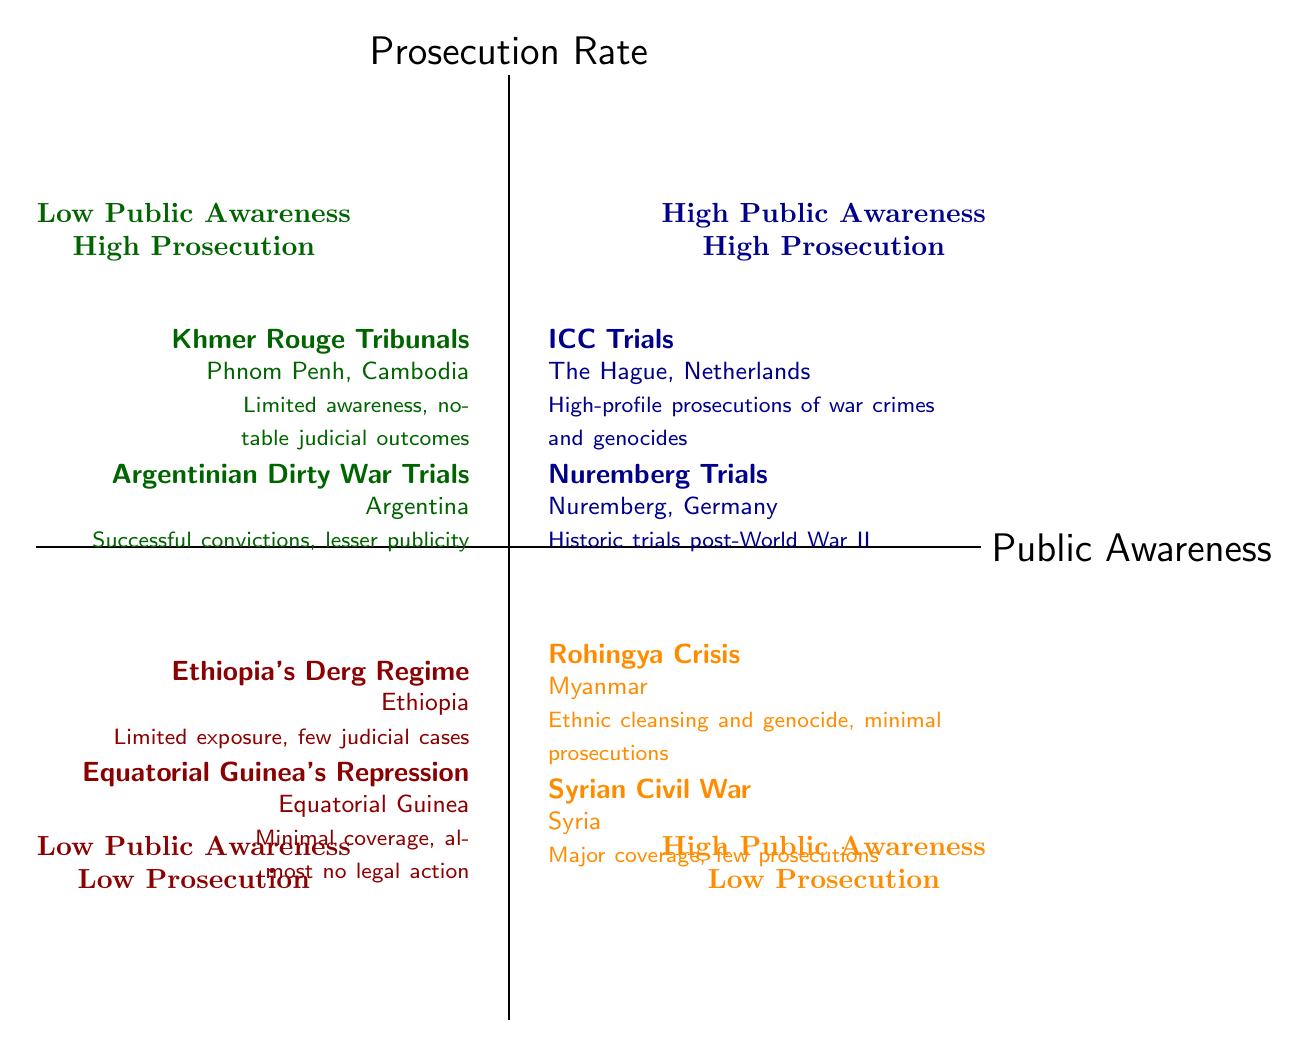What cases are located in the High Public Awareness and Low Prosecution quadrant? In the diagram, the quadrant titled "High Public Awareness Low Prosecution" shows cases that are highly covered by media but have fewer prosecutions. The cases listed here are the "Rohingya Crisis" and "Syrian Civil War."
Answer: Rohingya Crisis, Syrian Civil War How many cases are in the Low Public Awareness and Low Prosecution quadrant? The quadrant labeled "Low Public Awareness Low Prosecution" contains two cases listed, which are "Ethiopia's Derg Regime Repression" and "Equatorial Guinea's Political Repression." Therefore, the count of cases in this quadrant is two.
Answer: 2 Which case in the High Public Awareness and High Prosecution quadrant is from The Hague? The case listed in the "High Public Awareness High Prosecution" quadrant that is from The Hague is "ICC Trials." This is evident from the node detailing its location.
Answer: ICC Trials What is the relationship between the Rohingya Crisis and prosecution rates? The "Rohingya Crisis," located in the "High Public Awareness Low Prosecution" quadrant, indicates a high level of media coverage concerning human rights violations (specifically ethnic cleansing) but demonstrates minimal judicial actions taken against perpetrators. Hence, the relationship shows that despite high awareness, prosecution rates are low.
Answer: High awareness, low prosecution Which quadrant contains the case with notable judicial outcomes but limited public awareness? The case that has notable judicial outcomes but is marked by limited public awareness is categorized in the "Low Public Awareness High Prosecution" quadrant. The cases in this quadrant include the "Khmer Rouge Tribunals" and the "Argentinian Dirty War Trials," which highlight successes in prosecutions despite lesser-known status.
Answer: Low Public Awareness High Prosecution How many total cases are in the High Public Awareness quadrants combined? To find the total number of cases in the quadrants with high public awareness, we add the number of cases from both the "High Public Awareness High Prosecution" and "High Public Awareness Low Prosecution" quadrants. The first quadrant has two cases (ICC Trials, Nuremberg Trials), and the second quadrant also has two cases (Rohingya Crisis, Syrian Civil War), resulting in a total of four cases.
Answer: 4 Which country is associated with the Argentinian Dirty War Trials? The "Argentinian Dirty War Trials" are associated with Argentina as specified in the description of the case found in the "Low Public Awareness High Prosecution" quadrant.
Answer: Argentina How do the cases in the Low Public Awareness and High Prosecution quadrant compare to those in the Low Public Awareness and Low Prosecution quadrant? In comparing these two quadrants, the "Low Public Awareness High Prosecution" quadrant contains cases with successful prosecutions like the "Khmer Rouge Tribunals" and "Argentinian Dirty War Trials," while the "Low Public Awareness Low Prosecution" quadrant has cases like "Ethiopia's Derg Regime Repression" and "Equatorial Guinea's Political Repression," which have minimal legal actions. This shows that some human rights violations can still see judicial actions despite low awareness.
Answer: Successful prosecutions vs. minimal actions What is the significance of the Nuremberg Trials in the context of public awareness? The "Nuremberg Trials," found in the "High Public Awareness High Prosecution" quadrant, are historically significant as they were among the first instances of international legal accountability for war crimes, resulting in widespread public attention and numerous convictions. This illustrates a strong correlation between high public awareness and effective prosecution rates.
Answer: High significance in public awareness and accountability 